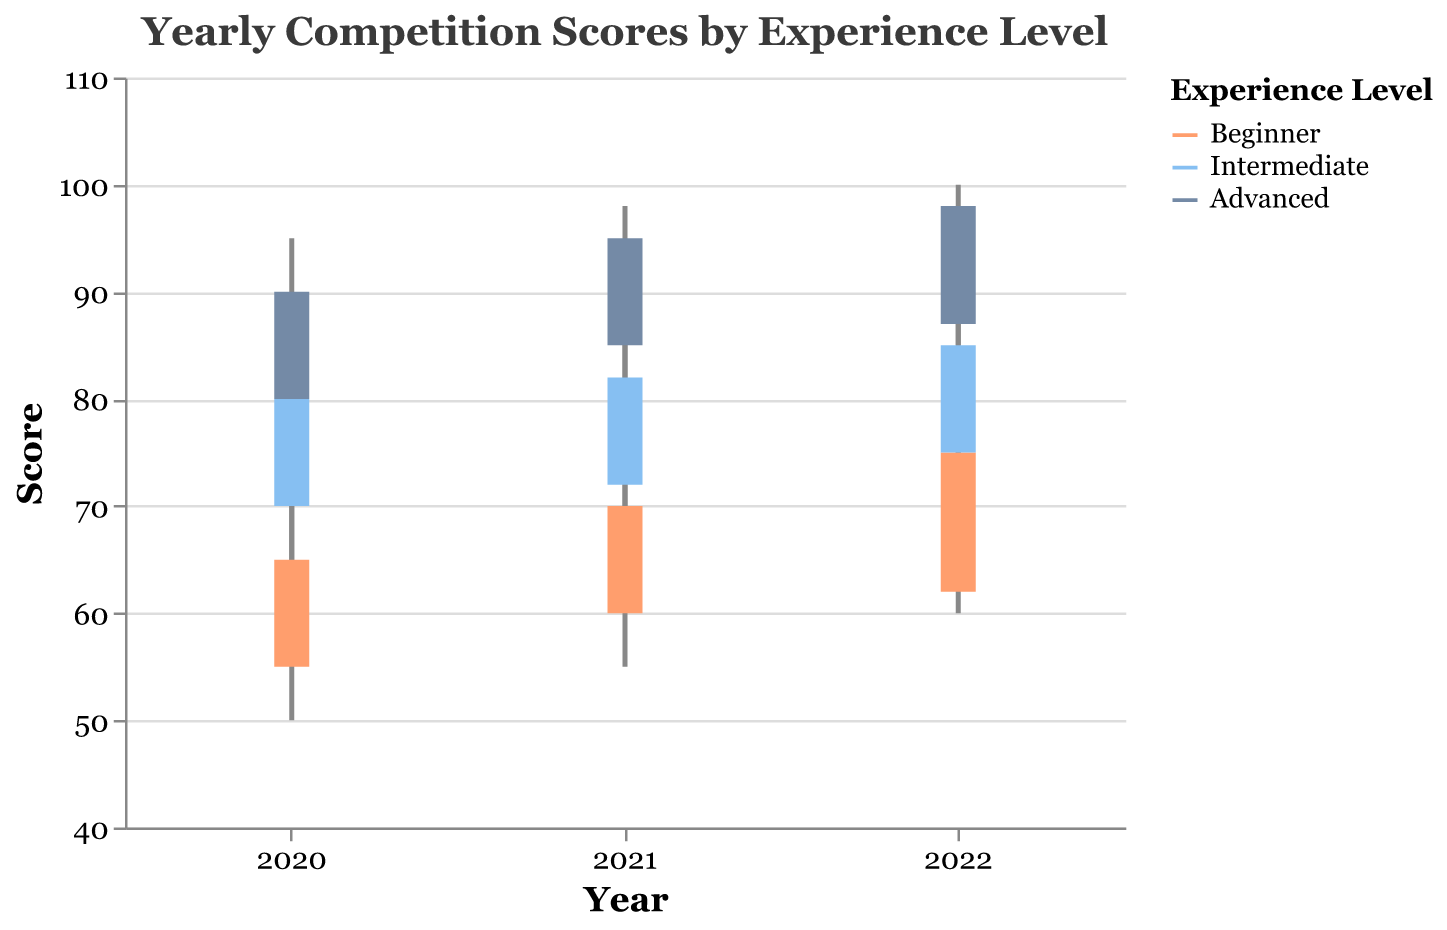What is the highest score for Advanced riders in 2022? Locate the data point for Advanced riders in the year 2022 and find the 'High' value. The highest score is depicted as the upper limit of the candlestick.
Answer: 100 What are the start and end scores for Beginner riders in 2020? For Beginner riders in 2020, the start score is the 'Open' value and the end score is the 'Close' value. These scores form the bar of the candlestick.
Answer: Open: 55, Close: 65 Which year had the largest score range for Intermediate riders? Calculate the score range for each year by subtracting the 'Low' from the 'High' for Intermediate riders and identify the year with the largest difference. 2021: 23 (88-65), 2020: 25 (85-60), 2022: 20 (90-70)
Answer: 2020 How did the closing scores for Advanced riders change from 2021 to 2022? Observe the 'Close' values for Advanced riders for the years 2021 and 2022 and find the difference between them. 2022 close: 98, 2021 close: 95, Change: 98-95
Answer: Increased by 3 Which experience level had the highest closing score in 2021? Look at the 'Close' values in 2021 for all experience levels and identify the highest value. 2021 Beginner close: 70, Intermediate close: 82, Advanced close: 95
Answer: Advanced What is the average high score for Beginner riders across all years? Sum the 'High' values for Beginner riders for all years, then divide by the number of years. (70 + 75 + 80) / 3 = 225 / 3
Answer: 75 Did the opening scores for Intermediate riders increase, decrease or stay the same from 2020 to 2021? Compare the 'Open' values for Intermediate riders from 2020 and 2021. 2020 open: 70, 2021 open: 72
Answer: Increased Which experience level shows the smallest change in opening scores from 2020 to 2022? Calculate the change in 'Open' scores from 2020 to 2022 for all experience levels and identify the smallest change. Beginner: 62-55=7, Intermediate: 75-70=5, Advanced: 87-80=7
Answer: Intermediate How did the score range for Beginner riders in 2022 compare to that in 2021? Calculate the score range for Beginner riders in 2021 and 2022 by subtracting 'Low' from 'High' and compare the two values. 2021 range: 75-55=20, 2022 range: 80-60=20
Answer: Same What is the median closing score for all riders in 2022? Collect all the 'Close' values for 2022, sort them, and find the median value. Values: 75 (Beginner), 85 (Intermediate), 98 (Advanced). Sorted: 75, 85, 98. Median: 85
Answer: 85 